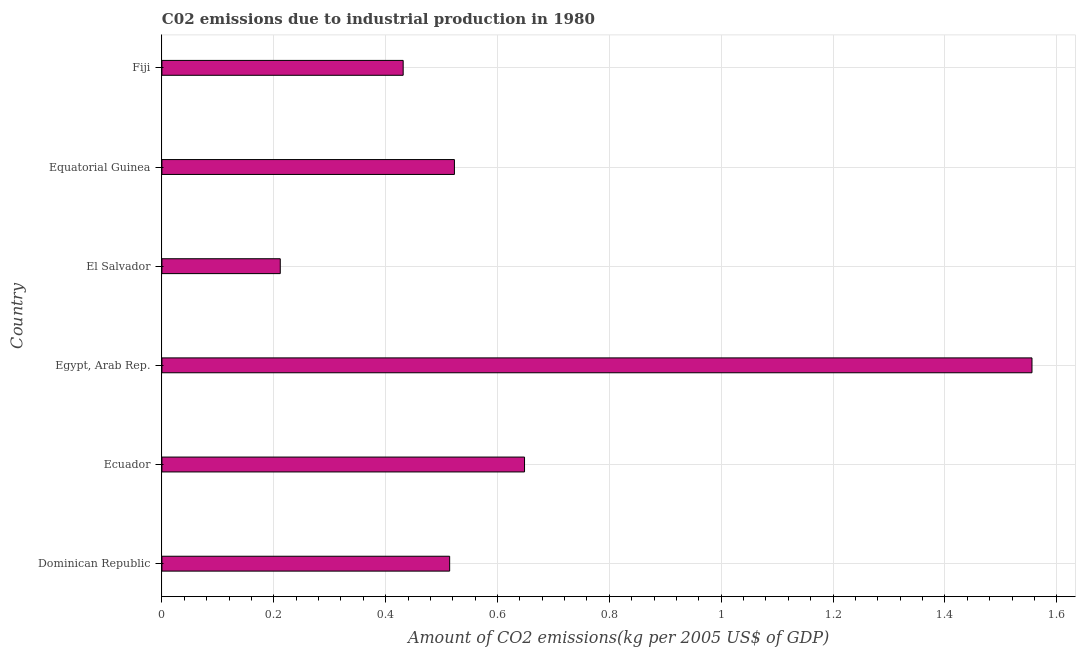Does the graph contain any zero values?
Keep it short and to the point. No. Does the graph contain grids?
Your answer should be very brief. Yes. What is the title of the graph?
Ensure brevity in your answer.  C02 emissions due to industrial production in 1980. What is the label or title of the X-axis?
Keep it short and to the point. Amount of CO2 emissions(kg per 2005 US$ of GDP). What is the label or title of the Y-axis?
Your response must be concise. Country. What is the amount of co2 emissions in Fiji?
Give a very brief answer. 0.43. Across all countries, what is the maximum amount of co2 emissions?
Make the answer very short. 1.56. Across all countries, what is the minimum amount of co2 emissions?
Provide a succinct answer. 0.21. In which country was the amount of co2 emissions maximum?
Keep it short and to the point. Egypt, Arab Rep. In which country was the amount of co2 emissions minimum?
Provide a succinct answer. El Salvador. What is the sum of the amount of co2 emissions?
Make the answer very short. 3.88. What is the difference between the amount of co2 emissions in Ecuador and El Salvador?
Your answer should be very brief. 0.44. What is the average amount of co2 emissions per country?
Offer a terse response. 0.65. What is the median amount of co2 emissions?
Your answer should be very brief. 0.52. In how many countries, is the amount of co2 emissions greater than 0.2 kg per 2005 US$ of GDP?
Make the answer very short. 6. Is the amount of co2 emissions in Ecuador less than that in Equatorial Guinea?
Ensure brevity in your answer.  No. Is the difference between the amount of co2 emissions in Ecuador and Fiji greater than the difference between any two countries?
Offer a very short reply. No. What is the difference between the highest and the second highest amount of co2 emissions?
Keep it short and to the point. 0.91. Is the sum of the amount of co2 emissions in Dominican Republic and Equatorial Guinea greater than the maximum amount of co2 emissions across all countries?
Ensure brevity in your answer.  No. What is the difference between the highest and the lowest amount of co2 emissions?
Your answer should be compact. 1.34. How many bars are there?
Provide a succinct answer. 6. How many countries are there in the graph?
Your answer should be compact. 6. What is the difference between two consecutive major ticks on the X-axis?
Provide a short and direct response. 0.2. What is the Amount of CO2 emissions(kg per 2005 US$ of GDP) of Dominican Republic?
Your answer should be very brief. 0.51. What is the Amount of CO2 emissions(kg per 2005 US$ of GDP) in Ecuador?
Provide a succinct answer. 0.65. What is the Amount of CO2 emissions(kg per 2005 US$ of GDP) in Egypt, Arab Rep.?
Provide a succinct answer. 1.56. What is the Amount of CO2 emissions(kg per 2005 US$ of GDP) in El Salvador?
Offer a terse response. 0.21. What is the Amount of CO2 emissions(kg per 2005 US$ of GDP) of Equatorial Guinea?
Ensure brevity in your answer.  0.52. What is the Amount of CO2 emissions(kg per 2005 US$ of GDP) in Fiji?
Provide a short and direct response. 0.43. What is the difference between the Amount of CO2 emissions(kg per 2005 US$ of GDP) in Dominican Republic and Ecuador?
Your answer should be very brief. -0.13. What is the difference between the Amount of CO2 emissions(kg per 2005 US$ of GDP) in Dominican Republic and Egypt, Arab Rep.?
Offer a terse response. -1.04. What is the difference between the Amount of CO2 emissions(kg per 2005 US$ of GDP) in Dominican Republic and El Salvador?
Give a very brief answer. 0.3. What is the difference between the Amount of CO2 emissions(kg per 2005 US$ of GDP) in Dominican Republic and Equatorial Guinea?
Provide a succinct answer. -0.01. What is the difference between the Amount of CO2 emissions(kg per 2005 US$ of GDP) in Dominican Republic and Fiji?
Ensure brevity in your answer.  0.08. What is the difference between the Amount of CO2 emissions(kg per 2005 US$ of GDP) in Ecuador and Egypt, Arab Rep.?
Your answer should be very brief. -0.91. What is the difference between the Amount of CO2 emissions(kg per 2005 US$ of GDP) in Ecuador and El Salvador?
Your answer should be compact. 0.44. What is the difference between the Amount of CO2 emissions(kg per 2005 US$ of GDP) in Ecuador and Equatorial Guinea?
Offer a terse response. 0.13. What is the difference between the Amount of CO2 emissions(kg per 2005 US$ of GDP) in Ecuador and Fiji?
Offer a terse response. 0.22. What is the difference between the Amount of CO2 emissions(kg per 2005 US$ of GDP) in Egypt, Arab Rep. and El Salvador?
Make the answer very short. 1.34. What is the difference between the Amount of CO2 emissions(kg per 2005 US$ of GDP) in Egypt, Arab Rep. and Equatorial Guinea?
Make the answer very short. 1.03. What is the difference between the Amount of CO2 emissions(kg per 2005 US$ of GDP) in Egypt, Arab Rep. and Fiji?
Make the answer very short. 1.12. What is the difference between the Amount of CO2 emissions(kg per 2005 US$ of GDP) in El Salvador and Equatorial Guinea?
Keep it short and to the point. -0.31. What is the difference between the Amount of CO2 emissions(kg per 2005 US$ of GDP) in El Salvador and Fiji?
Give a very brief answer. -0.22. What is the difference between the Amount of CO2 emissions(kg per 2005 US$ of GDP) in Equatorial Guinea and Fiji?
Offer a very short reply. 0.09. What is the ratio of the Amount of CO2 emissions(kg per 2005 US$ of GDP) in Dominican Republic to that in Ecuador?
Ensure brevity in your answer.  0.79. What is the ratio of the Amount of CO2 emissions(kg per 2005 US$ of GDP) in Dominican Republic to that in Egypt, Arab Rep.?
Your answer should be very brief. 0.33. What is the ratio of the Amount of CO2 emissions(kg per 2005 US$ of GDP) in Dominican Republic to that in El Salvador?
Your response must be concise. 2.43. What is the ratio of the Amount of CO2 emissions(kg per 2005 US$ of GDP) in Dominican Republic to that in Fiji?
Ensure brevity in your answer.  1.19. What is the ratio of the Amount of CO2 emissions(kg per 2005 US$ of GDP) in Ecuador to that in Egypt, Arab Rep.?
Your response must be concise. 0.42. What is the ratio of the Amount of CO2 emissions(kg per 2005 US$ of GDP) in Ecuador to that in El Salvador?
Provide a succinct answer. 3.06. What is the ratio of the Amount of CO2 emissions(kg per 2005 US$ of GDP) in Ecuador to that in Equatorial Guinea?
Your answer should be very brief. 1.24. What is the ratio of the Amount of CO2 emissions(kg per 2005 US$ of GDP) in Ecuador to that in Fiji?
Offer a terse response. 1.5. What is the ratio of the Amount of CO2 emissions(kg per 2005 US$ of GDP) in Egypt, Arab Rep. to that in El Salvador?
Your response must be concise. 7.35. What is the ratio of the Amount of CO2 emissions(kg per 2005 US$ of GDP) in Egypt, Arab Rep. to that in Equatorial Guinea?
Your response must be concise. 2.97. What is the ratio of the Amount of CO2 emissions(kg per 2005 US$ of GDP) in Egypt, Arab Rep. to that in Fiji?
Provide a short and direct response. 3.61. What is the ratio of the Amount of CO2 emissions(kg per 2005 US$ of GDP) in El Salvador to that in Equatorial Guinea?
Your response must be concise. 0.41. What is the ratio of the Amount of CO2 emissions(kg per 2005 US$ of GDP) in El Salvador to that in Fiji?
Make the answer very short. 0.49. What is the ratio of the Amount of CO2 emissions(kg per 2005 US$ of GDP) in Equatorial Guinea to that in Fiji?
Your answer should be very brief. 1.21. 